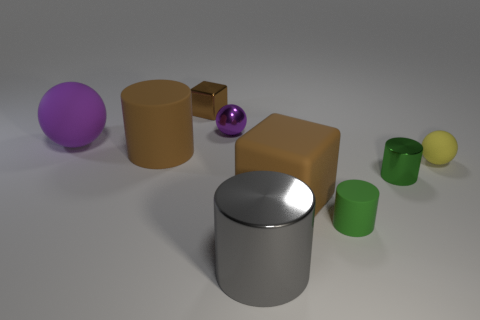Add 1 big red matte blocks. How many objects exist? 10 Subtract all balls. How many objects are left? 6 Add 8 large brown rubber cubes. How many large brown rubber cubes are left? 9 Add 4 brown rubber cylinders. How many brown rubber cylinders exist? 5 Subtract 0 blue spheres. How many objects are left? 9 Subtract all metallic blocks. Subtract all brown matte things. How many objects are left? 6 